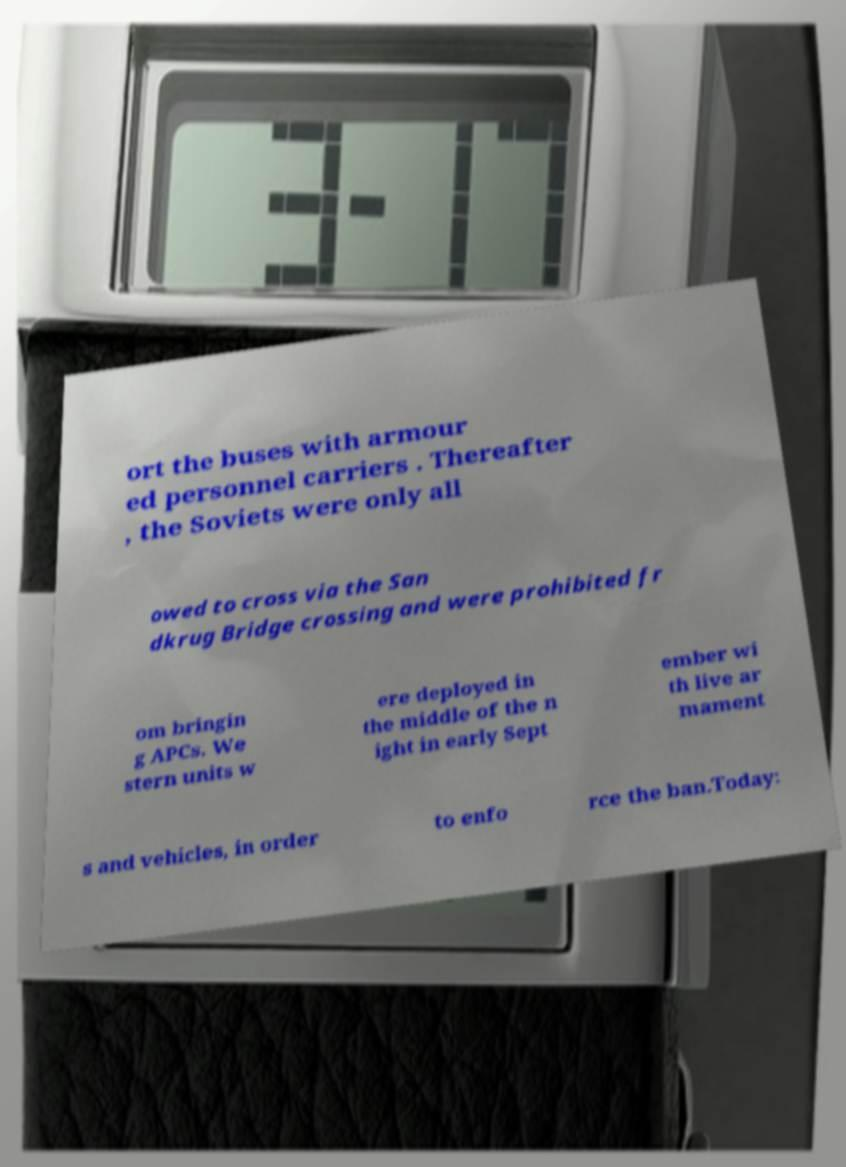There's text embedded in this image that I need extracted. Can you transcribe it verbatim? ort the buses with armour ed personnel carriers . Thereafter , the Soviets were only all owed to cross via the San dkrug Bridge crossing and were prohibited fr om bringin g APCs. We stern units w ere deployed in the middle of the n ight in early Sept ember wi th live ar mament s and vehicles, in order to enfo rce the ban.Today: 